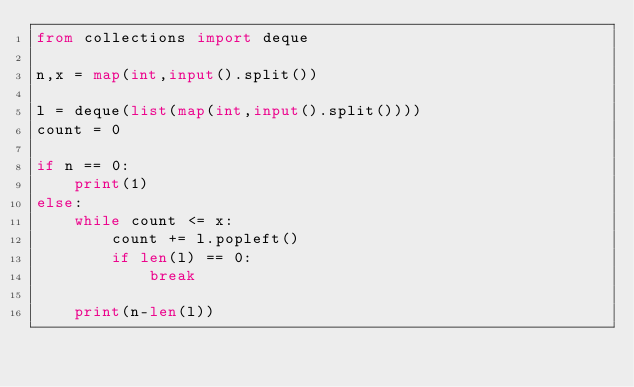Convert code to text. <code><loc_0><loc_0><loc_500><loc_500><_Python_>from collections import deque

n,x = map(int,input().split())

l = deque(list(map(int,input().split())))
count = 0

if n == 0:
    print(1)
else:
    while count <= x:
        count += l.popleft()
        if len(l) == 0:
            break

    print(n-len(l))</code> 